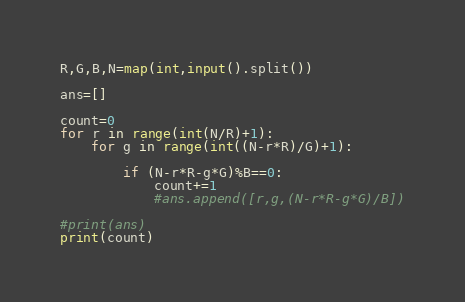Convert code to text. <code><loc_0><loc_0><loc_500><loc_500><_Python_>R,G,B,N=map(int,input().split())

ans=[]

count=0
for r in range(int(N/R)+1):
    for g in range(int((N-r*R)/G)+1):
        
        if (N-r*R-g*G)%B==0:
            count+=1
            #ans.append([r,g,(N-r*R-g*G)/B])

#print(ans)
print(count)</code> 